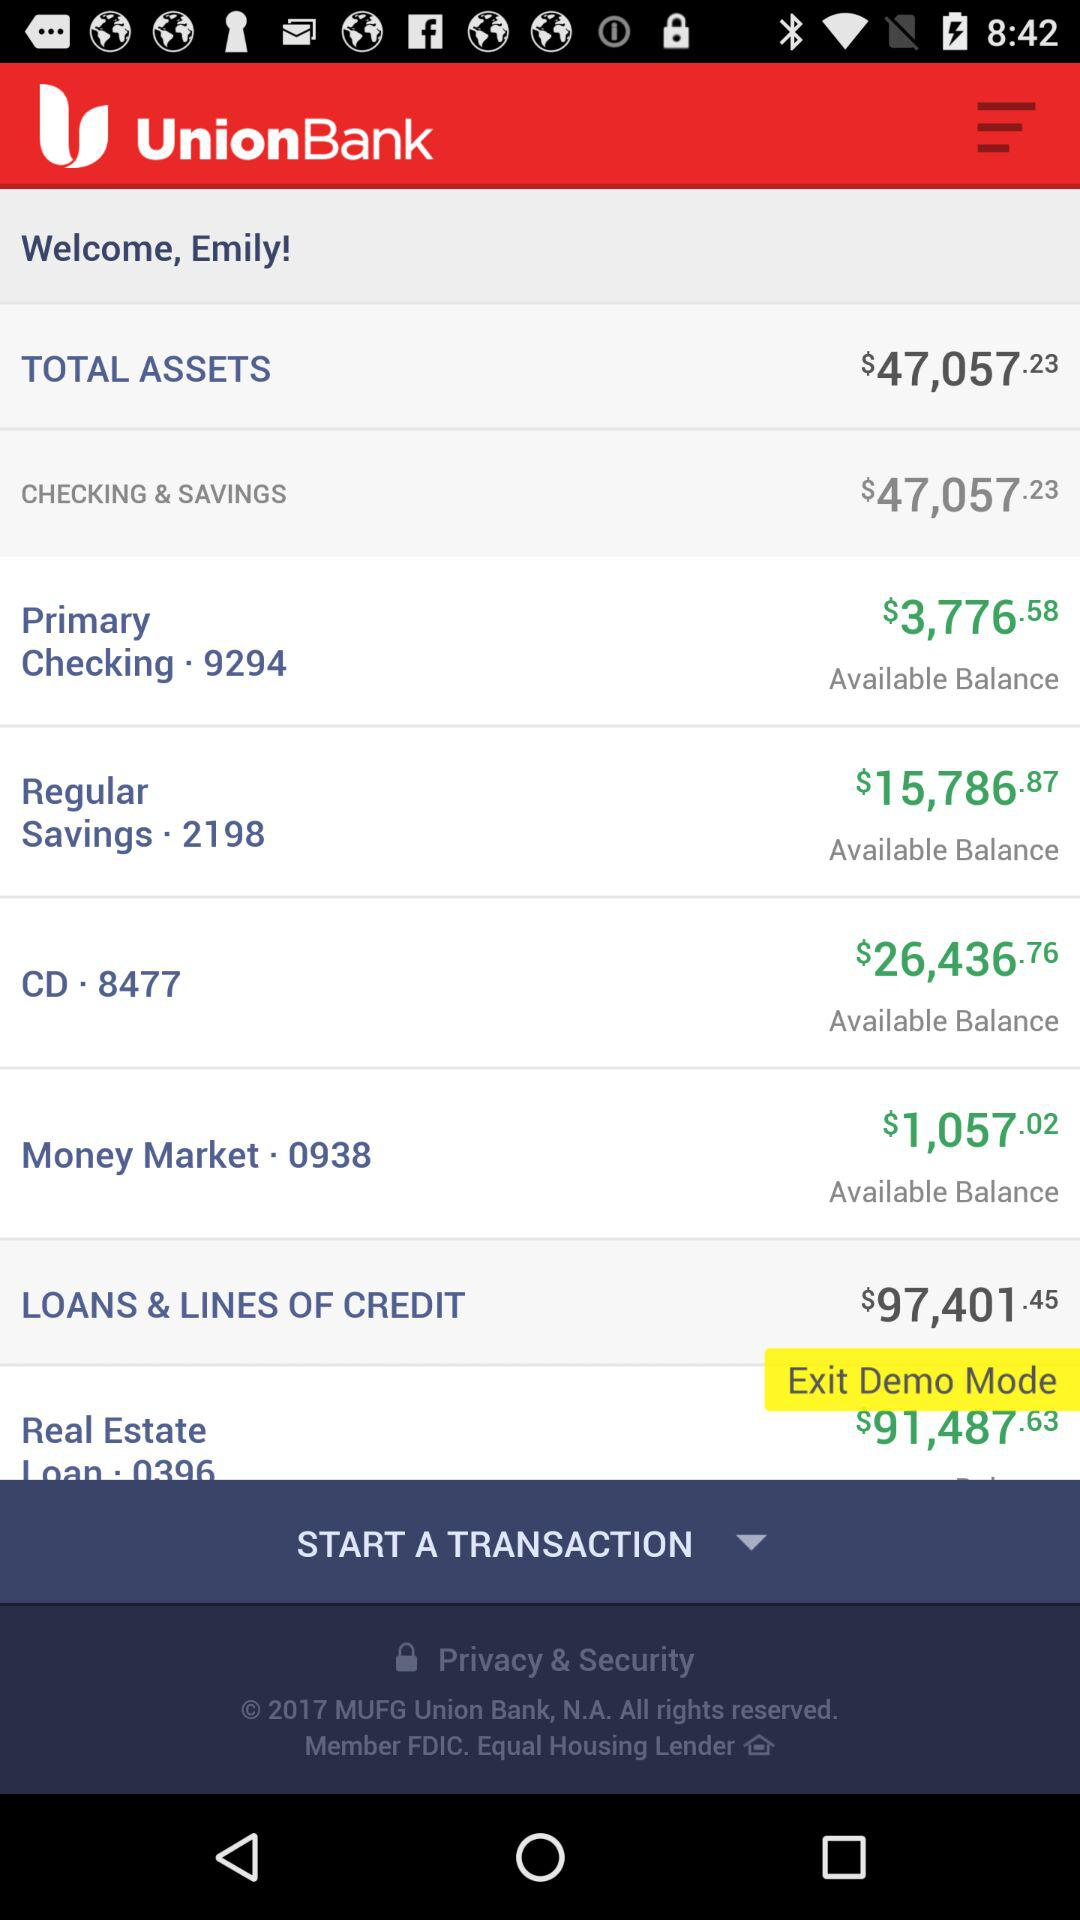What's the available balance in primary checking? The available balance in primary checking is $3,776.58. 